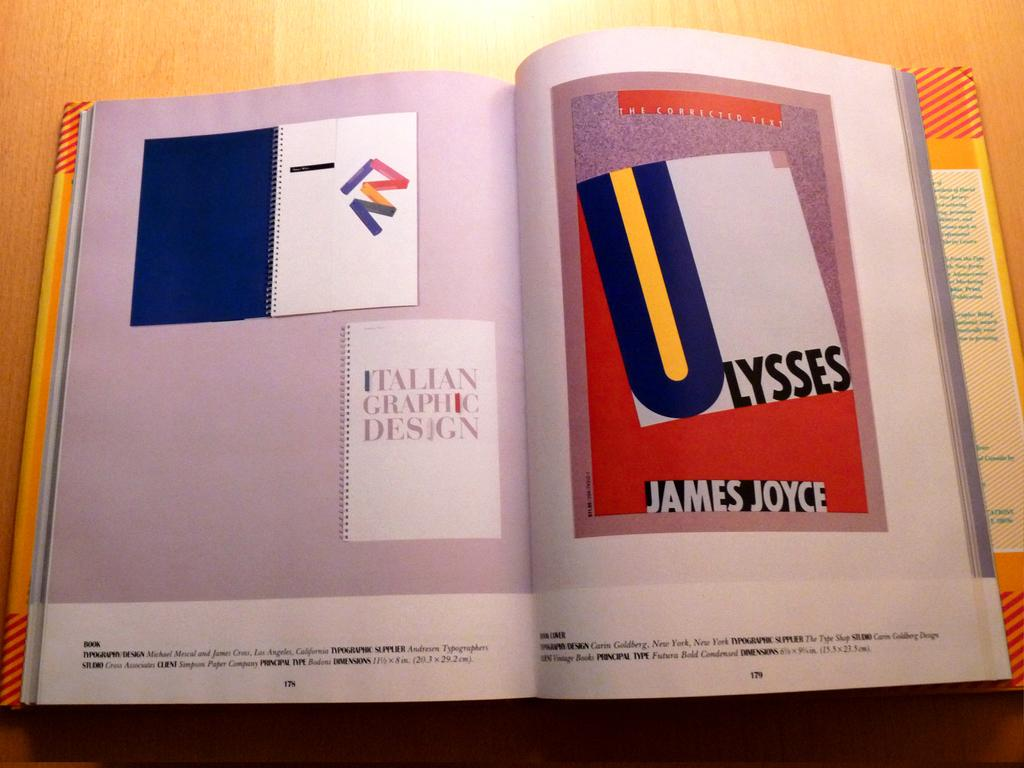<image>
Share a concise interpretation of the image provided. a magazine article is open to a page with words Ulysses by James Joyce 